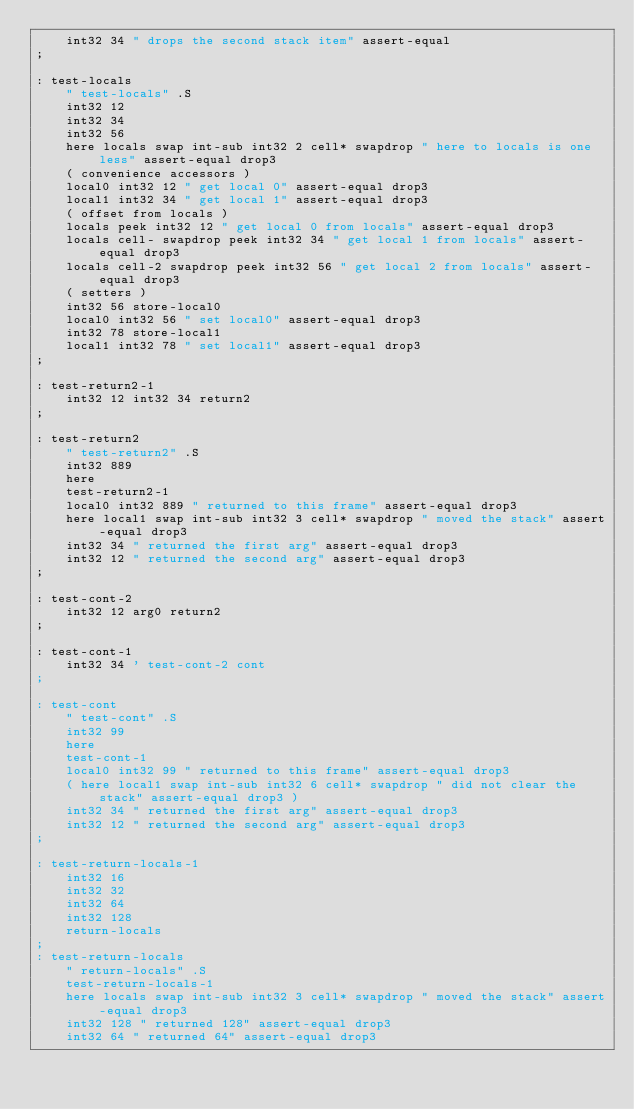Convert code to text. <code><loc_0><loc_0><loc_500><loc_500><_Forth_>    int32 34 " drops the second stack item" assert-equal
;

: test-locals
    " test-locals" .S
    int32 12
    int32 34
    int32 56
    here locals swap int-sub int32 2 cell* swapdrop " here to locals is one less" assert-equal drop3
    ( convenience accessors )
    local0 int32 12 " get local 0" assert-equal drop3
    local1 int32 34 " get local 1" assert-equal drop3
    ( offset from locals )
    locals peek int32 12 " get local 0 from locals" assert-equal drop3
    locals cell- swapdrop peek int32 34 " get local 1 from locals" assert-equal drop3
    locals cell-2 swapdrop peek int32 56 " get local 2 from locals" assert-equal drop3
    ( setters )
    int32 56 store-local0
    local0 int32 56 " set local0" assert-equal drop3
    int32 78 store-local1
    local1 int32 78 " set local1" assert-equal drop3    
;

: test-return2-1
    int32 12 int32 34 return2
;

: test-return2
    " test-return2" .S
    int32 889
    here
    test-return2-1
    local0 int32 889 " returned to this frame" assert-equal drop3
    here local1 swap int-sub int32 3 cell* swapdrop " moved the stack" assert-equal drop3
    int32 34 " returned the first arg" assert-equal drop3
    int32 12 " returned the second arg" assert-equal drop3
;

: test-cont-2
    int32 12 arg0 return2
;

: test-cont-1
    int32 34 ' test-cont-2 cont
;

: test-cont
    " test-cont" .S
    int32 99
    here
    test-cont-1
    local0 int32 99 " returned to this frame" assert-equal drop3
    ( here local1 swap int-sub int32 6 cell* swapdrop " did not clear the stack" assert-equal drop3 )
    int32 34 " returned the first arg" assert-equal drop3
    int32 12 " returned the second arg" assert-equal drop3
;

: test-return-locals-1
    int32 16
    int32 32
    int32 64
    int32 128
    return-locals
;
: test-return-locals
    " return-locals" .S
    test-return-locals-1
    here locals swap int-sub int32 3 cell* swapdrop " moved the stack" assert-equal drop3
    int32 128 " returned 128" assert-equal drop3
    int32 64 " returned 64" assert-equal drop3</code> 